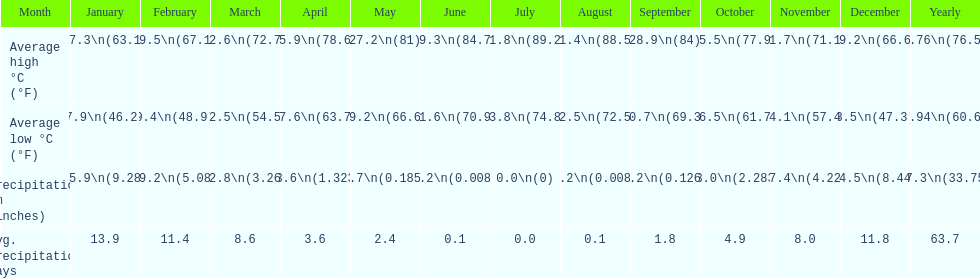Would you be able to parse every entry in this table? {'header': ['Month', 'January', 'February', 'March', 'April', 'May', 'June', 'July', 'August', 'September', 'October', 'November', 'December', 'Yearly'], 'rows': [['Average high °C (°F)', '17.3\\n(63.1)', '19.5\\n(67.1)', '22.6\\n(72.7)', '25.9\\n(78.6)', '27.2\\n(81)', '29.3\\n(84.7)', '31.8\\n(89.2)', '31.4\\n(88.5)', '28.9\\n(84)', '25.5\\n(77.9)', '21.7\\n(71.1)', '19.2\\n(66.6)', '24.76\\n(76.57)'], ['Average low °C (°F)', '7.9\\n(46.2)', '9.4\\n(48.9)', '12.5\\n(54.5)', '17.6\\n(63.7)', '19.2\\n(66.6)', '21.6\\n(70.9)', '23.8\\n(74.8)', '22.5\\n(72.5)', '20.7\\n(69.3)', '16.5\\n(61.7)', '14.1\\n(57.4)', '8.5\\n(47.3)', '15.94\\n(60.69)'], ['Precipitation mm (inches)', '235.9\\n(9.287)', '129.2\\n(5.087)', '82.8\\n(3.26)', '33.6\\n(1.323)', '4.7\\n(0.185)', '0.2\\n(0.008)', '0.0\\n(0)', '0.2\\n(0.008)', '3.2\\n(0.126)', '58.0\\n(2.283)', '107.4\\n(4.228)', '214.5\\n(8.445)', '857.3\\n(33.752)'], ['Avg. precipitation days', '13.9', '11.4', '8.6', '3.6', '2.4', '0.1', '0.0', '0.1', '1.8', '4.9', '8.0', '11.8', '63.7']]} Which country is haifa in? Israel. 